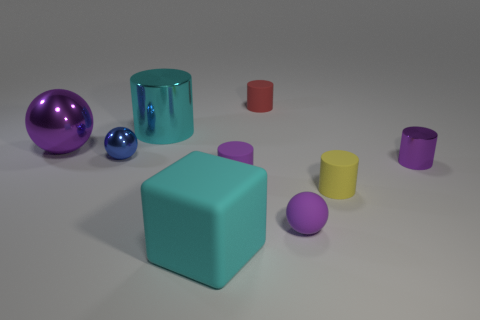Subtract all purple cylinders. How many cylinders are left? 3 Subtract all yellow cylinders. How many cylinders are left? 4 Add 1 small yellow cylinders. How many objects exist? 10 Subtract all tiny yellow rubber cylinders. Subtract all big purple matte objects. How many objects are left? 8 Add 3 big purple things. How many big purple things are left? 4 Add 5 red things. How many red things exist? 6 Subtract 1 yellow cylinders. How many objects are left? 8 Subtract all spheres. How many objects are left? 6 Subtract 1 blocks. How many blocks are left? 0 Subtract all cyan spheres. Subtract all yellow cylinders. How many spheres are left? 3 